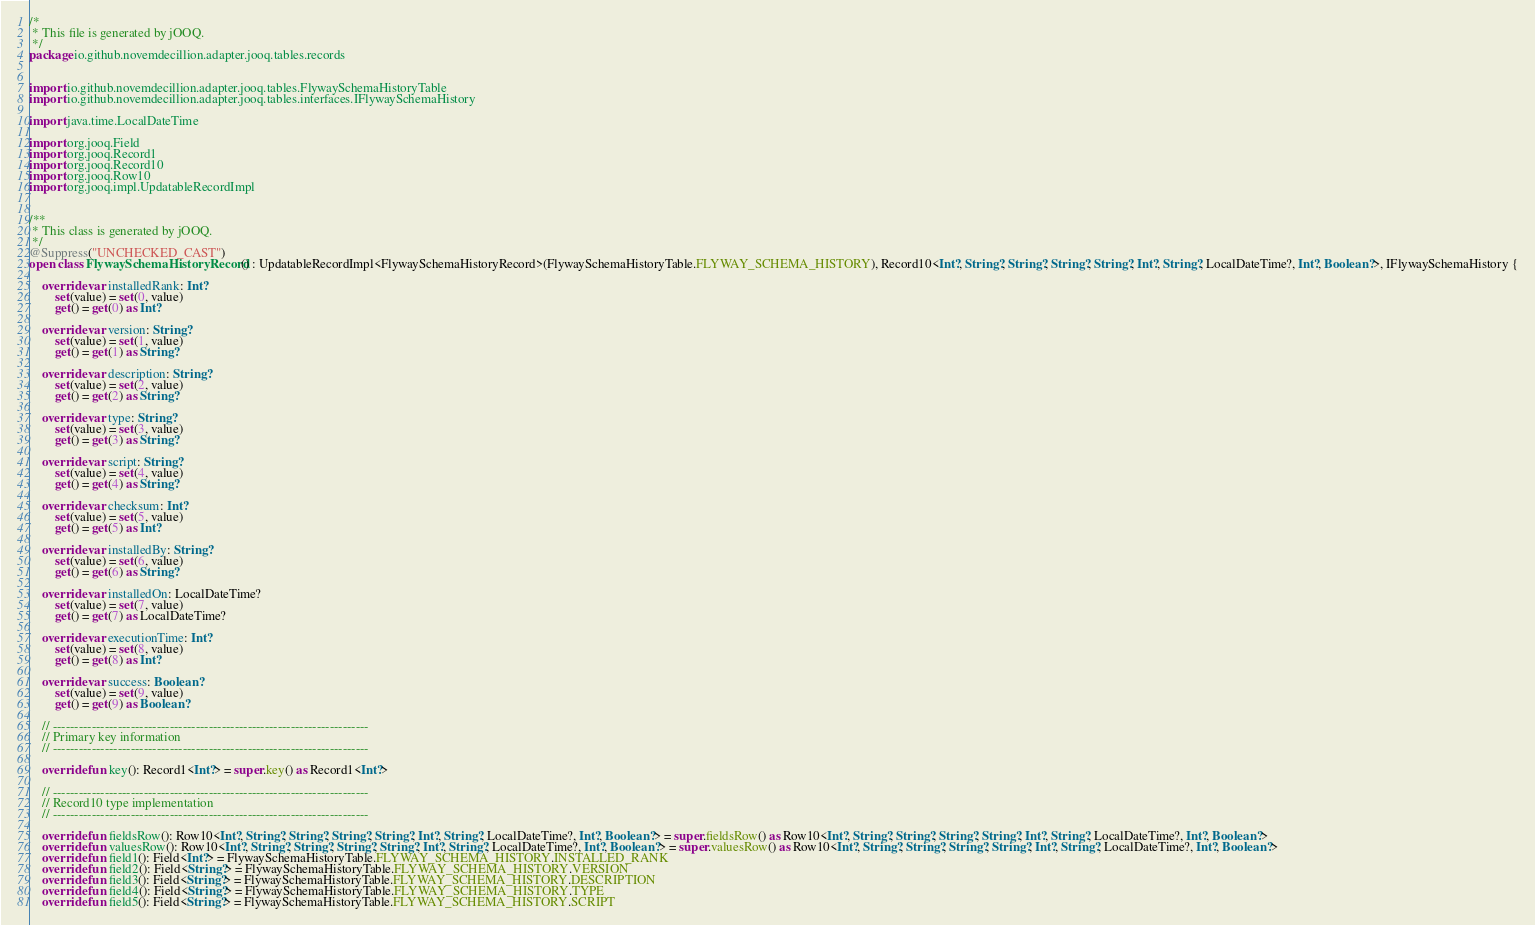Convert code to text. <code><loc_0><loc_0><loc_500><loc_500><_Kotlin_>/*
 * This file is generated by jOOQ.
 */
package io.github.novemdecillion.adapter.jooq.tables.records


import io.github.novemdecillion.adapter.jooq.tables.FlywaySchemaHistoryTable
import io.github.novemdecillion.adapter.jooq.tables.interfaces.IFlywaySchemaHistory

import java.time.LocalDateTime

import org.jooq.Field
import org.jooq.Record1
import org.jooq.Record10
import org.jooq.Row10
import org.jooq.impl.UpdatableRecordImpl


/**
 * This class is generated by jOOQ.
 */
@Suppress("UNCHECKED_CAST")
open class FlywaySchemaHistoryRecord() : UpdatableRecordImpl<FlywaySchemaHistoryRecord>(FlywaySchemaHistoryTable.FLYWAY_SCHEMA_HISTORY), Record10<Int?, String?, String?, String?, String?, Int?, String?, LocalDateTime?, Int?, Boolean?>, IFlywaySchemaHistory {

    override var installedRank: Int?
        set(value) = set(0, value)
        get() = get(0) as Int?

    override var version: String?
        set(value) = set(1, value)
        get() = get(1) as String?

    override var description: String?
        set(value) = set(2, value)
        get() = get(2) as String?

    override var type: String?
        set(value) = set(3, value)
        get() = get(3) as String?

    override var script: String?
        set(value) = set(4, value)
        get() = get(4) as String?

    override var checksum: Int?
        set(value) = set(5, value)
        get() = get(5) as Int?

    override var installedBy: String?
        set(value) = set(6, value)
        get() = get(6) as String?

    override var installedOn: LocalDateTime?
        set(value) = set(7, value)
        get() = get(7) as LocalDateTime?

    override var executionTime: Int?
        set(value) = set(8, value)
        get() = get(8) as Int?

    override var success: Boolean?
        set(value) = set(9, value)
        get() = get(9) as Boolean?

    // -------------------------------------------------------------------------
    // Primary key information
    // -------------------------------------------------------------------------

    override fun key(): Record1<Int?> = super.key() as Record1<Int?>

    // -------------------------------------------------------------------------
    // Record10 type implementation
    // -------------------------------------------------------------------------

    override fun fieldsRow(): Row10<Int?, String?, String?, String?, String?, Int?, String?, LocalDateTime?, Int?, Boolean?> = super.fieldsRow() as Row10<Int?, String?, String?, String?, String?, Int?, String?, LocalDateTime?, Int?, Boolean?>
    override fun valuesRow(): Row10<Int?, String?, String?, String?, String?, Int?, String?, LocalDateTime?, Int?, Boolean?> = super.valuesRow() as Row10<Int?, String?, String?, String?, String?, Int?, String?, LocalDateTime?, Int?, Boolean?>
    override fun field1(): Field<Int?> = FlywaySchemaHistoryTable.FLYWAY_SCHEMA_HISTORY.INSTALLED_RANK
    override fun field2(): Field<String?> = FlywaySchemaHistoryTable.FLYWAY_SCHEMA_HISTORY.VERSION
    override fun field3(): Field<String?> = FlywaySchemaHistoryTable.FLYWAY_SCHEMA_HISTORY.DESCRIPTION
    override fun field4(): Field<String?> = FlywaySchemaHistoryTable.FLYWAY_SCHEMA_HISTORY.TYPE
    override fun field5(): Field<String?> = FlywaySchemaHistoryTable.FLYWAY_SCHEMA_HISTORY.SCRIPT</code> 